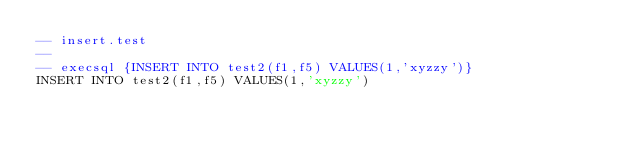Convert code to text. <code><loc_0><loc_0><loc_500><loc_500><_SQL_>-- insert.test
-- 
-- execsql {INSERT INTO test2(f1,f5) VALUES(1,'xyzzy')}
INSERT INTO test2(f1,f5) VALUES(1,'xyzzy')</code> 